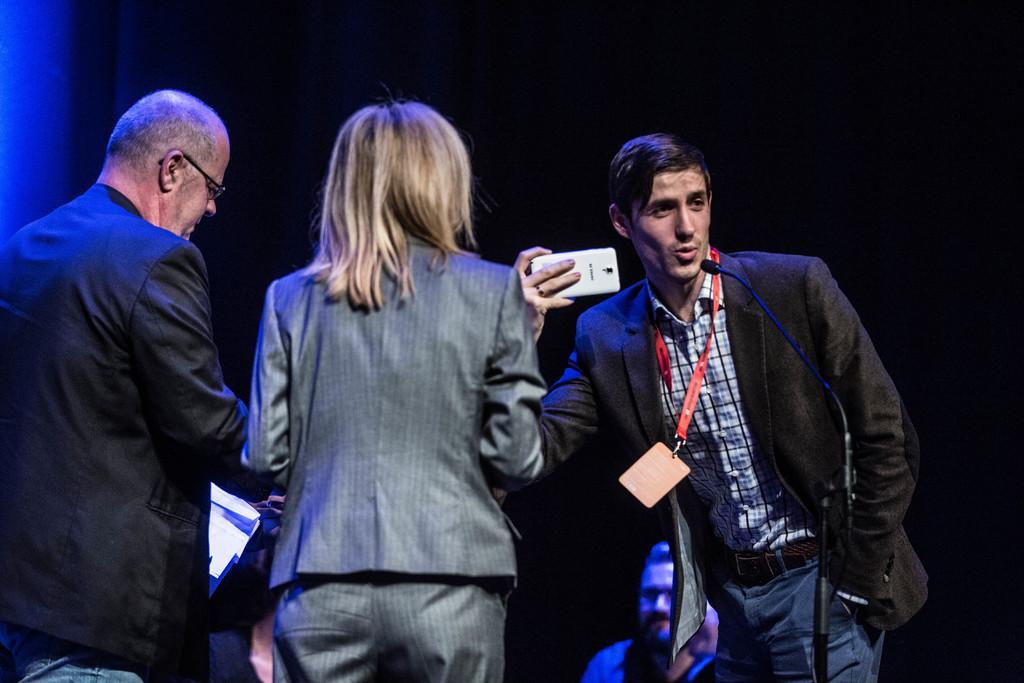In one or two sentences, can you explain what this image depicts? In this image, we can see a person wearing clothes and standing in front of the mic. This person is holding a mobile phone with his hand. There are two persons standing and wearing clothes. There is an another person at the bottom of the image. 